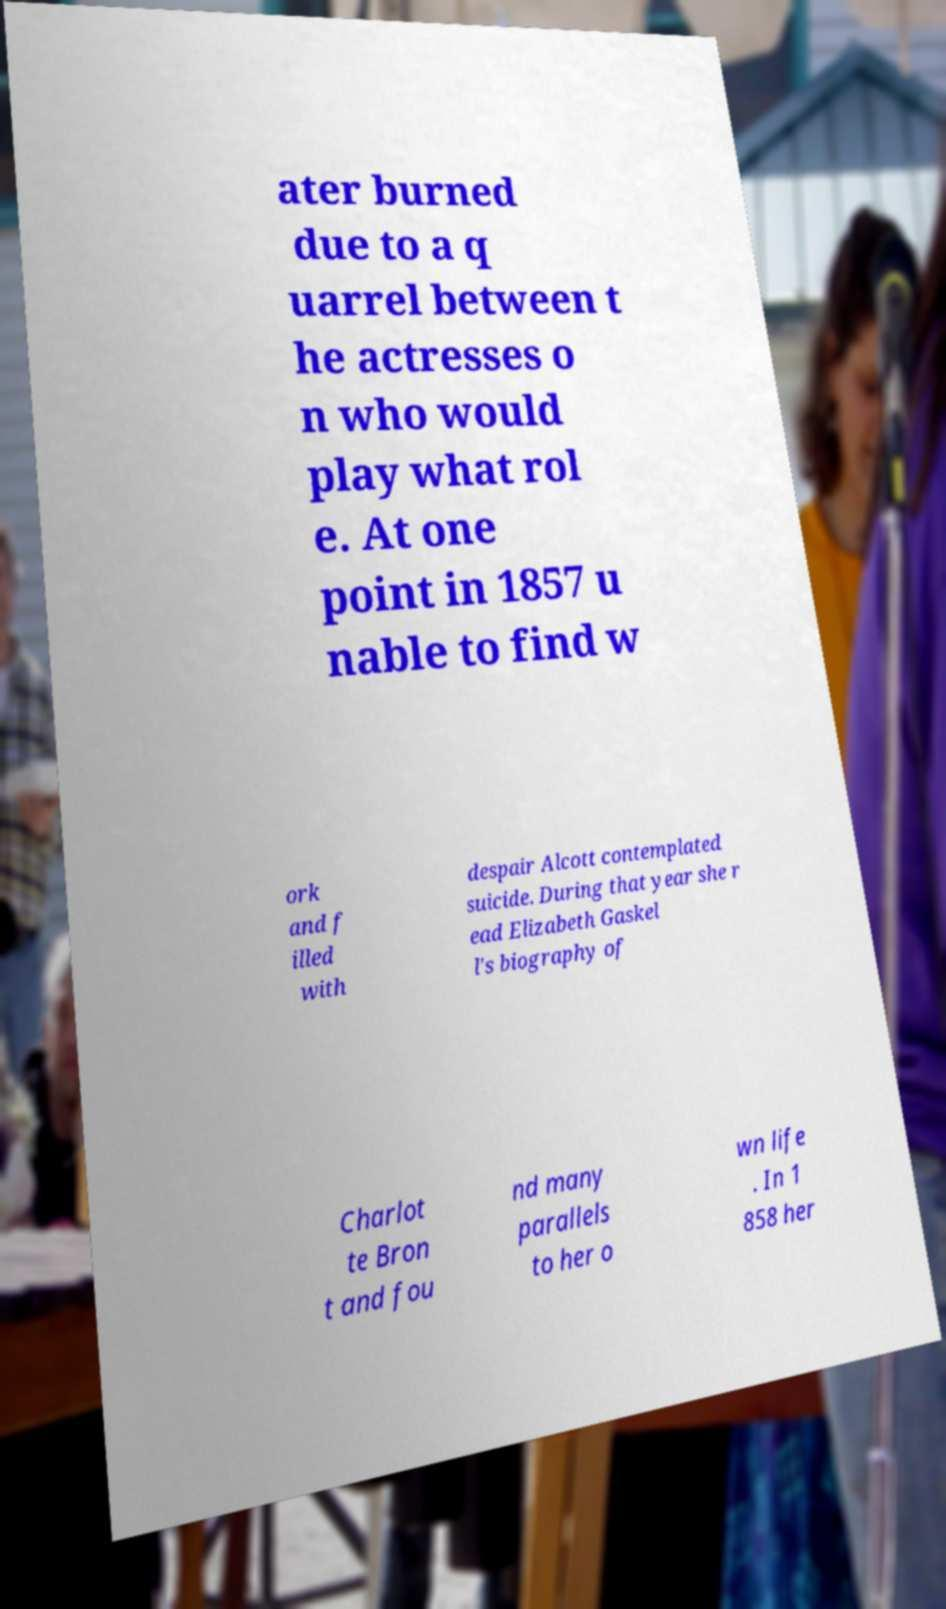Please identify and transcribe the text found in this image. ater burned due to a q uarrel between t he actresses o n who would play what rol e. At one point in 1857 u nable to find w ork and f illed with despair Alcott contemplated suicide. During that year she r ead Elizabeth Gaskel l's biography of Charlot te Bron t and fou nd many parallels to her o wn life . In 1 858 her 